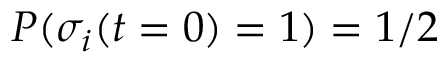Convert formula to latex. <formula><loc_0><loc_0><loc_500><loc_500>P ( \sigma _ { i } ( t = 0 ) = 1 ) = 1 / 2</formula> 